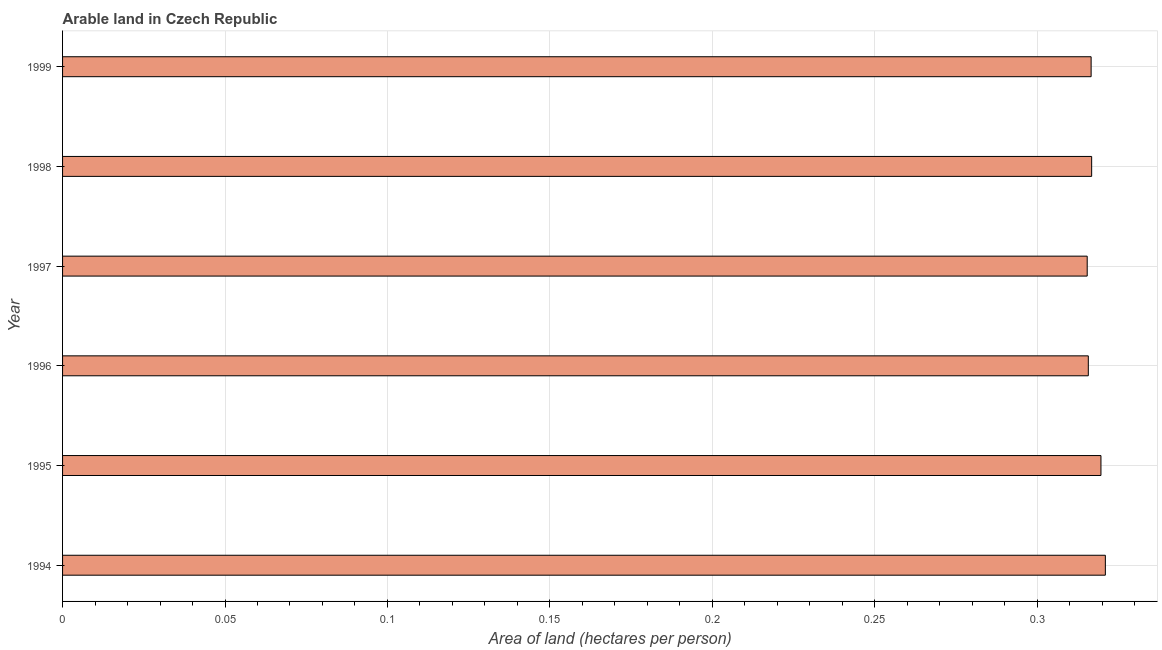Does the graph contain any zero values?
Offer a terse response. No. What is the title of the graph?
Provide a short and direct response. Arable land in Czech Republic. What is the label or title of the X-axis?
Provide a short and direct response. Area of land (hectares per person). What is the area of arable land in 1997?
Offer a very short reply. 0.32. Across all years, what is the maximum area of arable land?
Offer a very short reply. 0.32. Across all years, what is the minimum area of arable land?
Provide a short and direct response. 0.32. What is the sum of the area of arable land?
Your answer should be compact. 1.91. What is the difference between the area of arable land in 1994 and 1995?
Offer a very short reply. 0. What is the average area of arable land per year?
Provide a succinct answer. 0.32. What is the median area of arable land?
Give a very brief answer. 0.32. Do a majority of the years between 1994 and 1996 (inclusive) have area of arable land greater than 0.09 hectares per person?
Provide a short and direct response. Yes. What is the ratio of the area of arable land in 1995 to that in 1998?
Ensure brevity in your answer.  1.01. Is the area of arable land in 1994 less than that in 1996?
Your response must be concise. No. What is the difference between the highest and the second highest area of arable land?
Keep it short and to the point. 0. In how many years, is the area of arable land greater than the average area of arable land taken over all years?
Give a very brief answer. 2. How many bars are there?
Provide a short and direct response. 6. Are all the bars in the graph horizontal?
Offer a very short reply. Yes. How many years are there in the graph?
Your answer should be very brief. 6. Are the values on the major ticks of X-axis written in scientific E-notation?
Ensure brevity in your answer.  No. What is the Area of land (hectares per person) of 1994?
Offer a terse response. 0.32. What is the Area of land (hectares per person) of 1995?
Provide a short and direct response. 0.32. What is the Area of land (hectares per person) of 1996?
Your response must be concise. 0.32. What is the Area of land (hectares per person) of 1997?
Offer a very short reply. 0.32. What is the Area of land (hectares per person) of 1998?
Make the answer very short. 0.32. What is the Area of land (hectares per person) in 1999?
Your answer should be very brief. 0.32. What is the difference between the Area of land (hectares per person) in 1994 and 1995?
Your response must be concise. 0. What is the difference between the Area of land (hectares per person) in 1994 and 1996?
Provide a succinct answer. 0.01. What is the difference between the Area of land (hectares per person) in 1994 and 1997?
Your answer should be very brief. 0.01. What is the difference between the Area of land (hectares per person) in 1994 and 1998?
Your answer should be very brief. 0. What is the difference between the Area of land (hectares per person) in 1994 and 1999?
Offer a terse response. 0. What is the difference between the Area of land (hectares per person) in 1995 and 1996?
Provide a short and direct response. 0. What is the difference between the Area of land (hectares per person) in 1995 and 1997?
Provide a short and direct response. 0. What is the difference between the Area of land (hectares per person) in 1995 and 1998?
Provide a short and direct response. 0. What is the difference between the Area of land (hectares per person) in 1995 and 1999?
Your answer should be very brief. 0. What is the difference between the Area of land (hectares per person) in 1996 and 1997?
Offer a very short reply. 0. What is the difference between the Area of land (hectares per person) in 1996 and 1998?
Provide a succinct answer. -0. What is the difference between the Area of land (hectares per person) in 1996 and 1999?
Give a very brief answer. -0. What is the difference between the Area of land (hectares per person) in 1997 and 1998?
Your response must be concise. -0. What is the difference between the Area of land (hectares per person) in 1997 and 1999?
Your answer should be very brief. -0. What is the difference between the Area of land (hectares per person) in 1998 and 1999?
Provide a succinct answer. 0. What is the ratio of the Area of land (hectares per person) in 1994 to that in 1997?
Ensure brevity in your answer.  1.02. What is the ratio of the Area of land (hectares per person) in 1994 to that in 1999?
Provide a short and direct response. 1.01. What is the ratio of the Area of land (hectares per person) in 1996 to that in 1997?
Provide a short and direct response. 1. What is the ratio of the Area of land (hectares per person) in 1997 to that in 1999?
Your answer should be very brief. 1. 